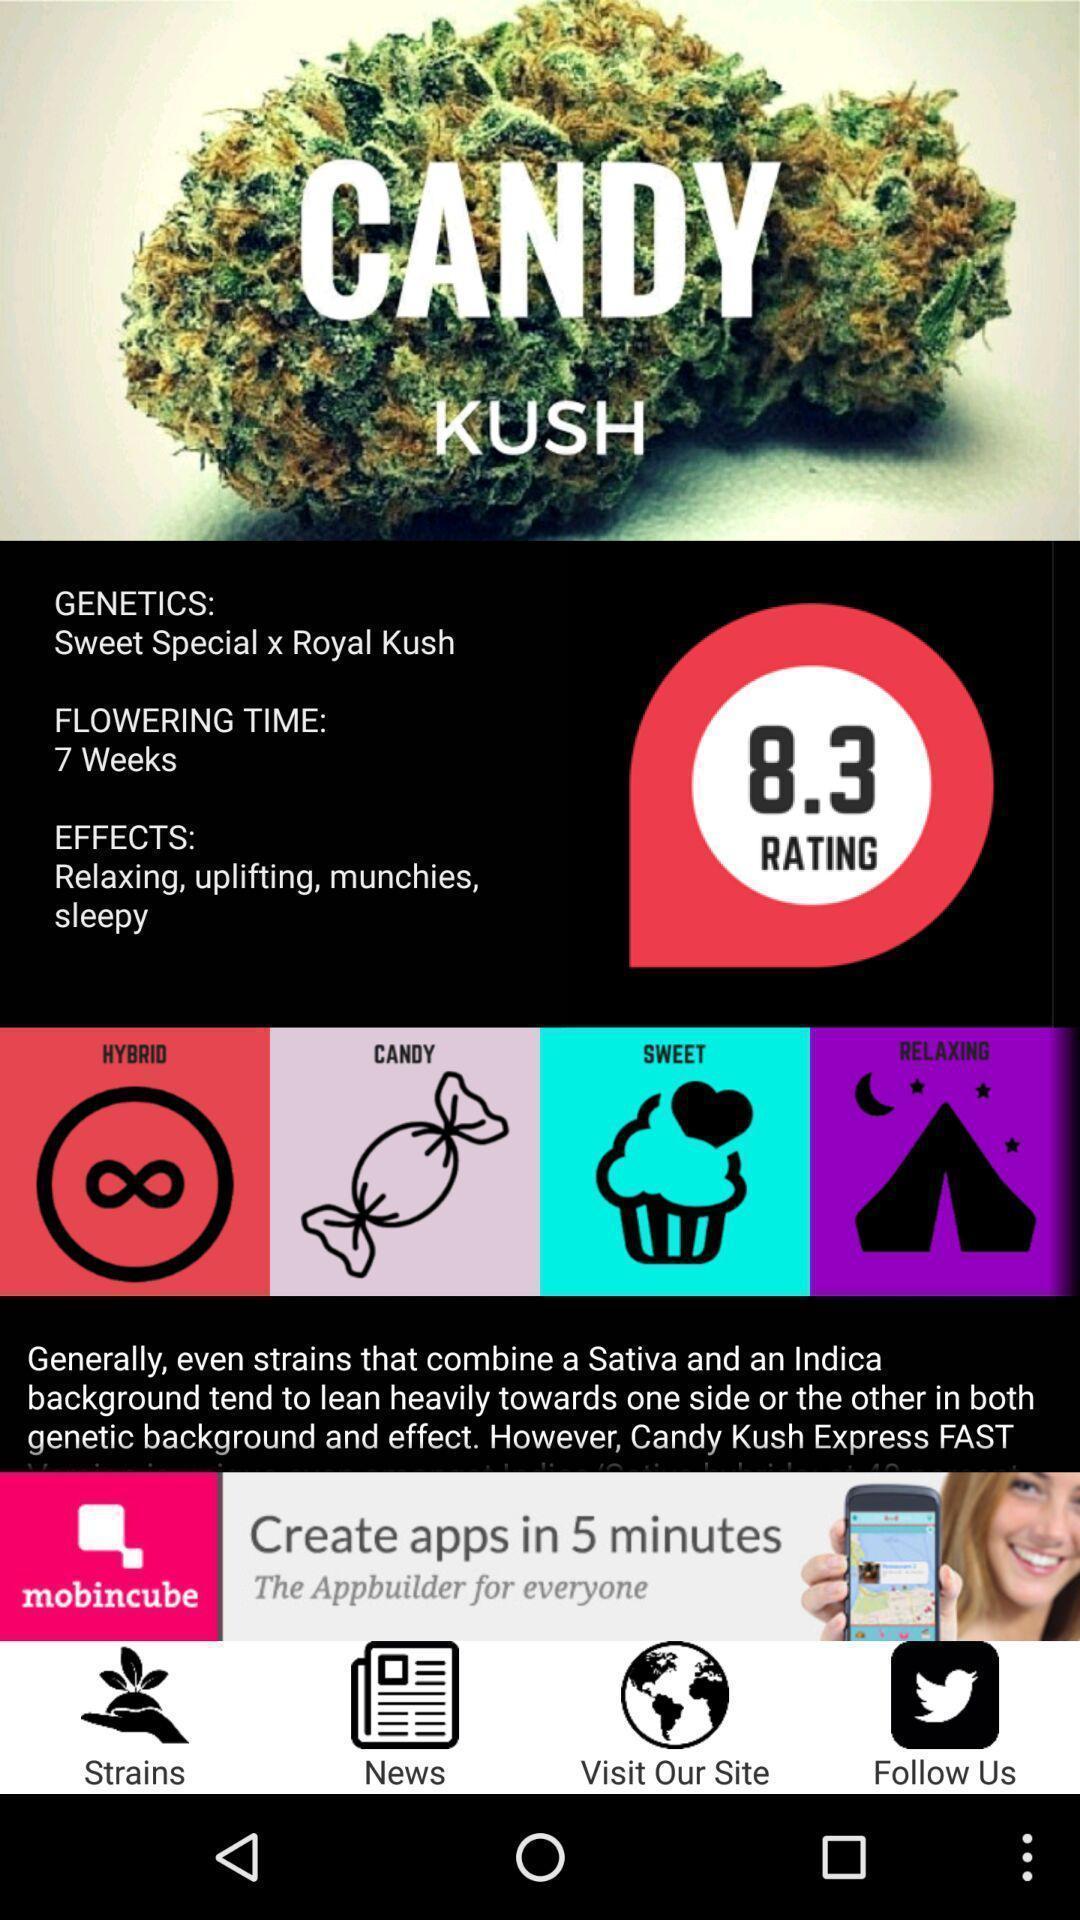Describe the content in this image. Page showing the home page of social app. 